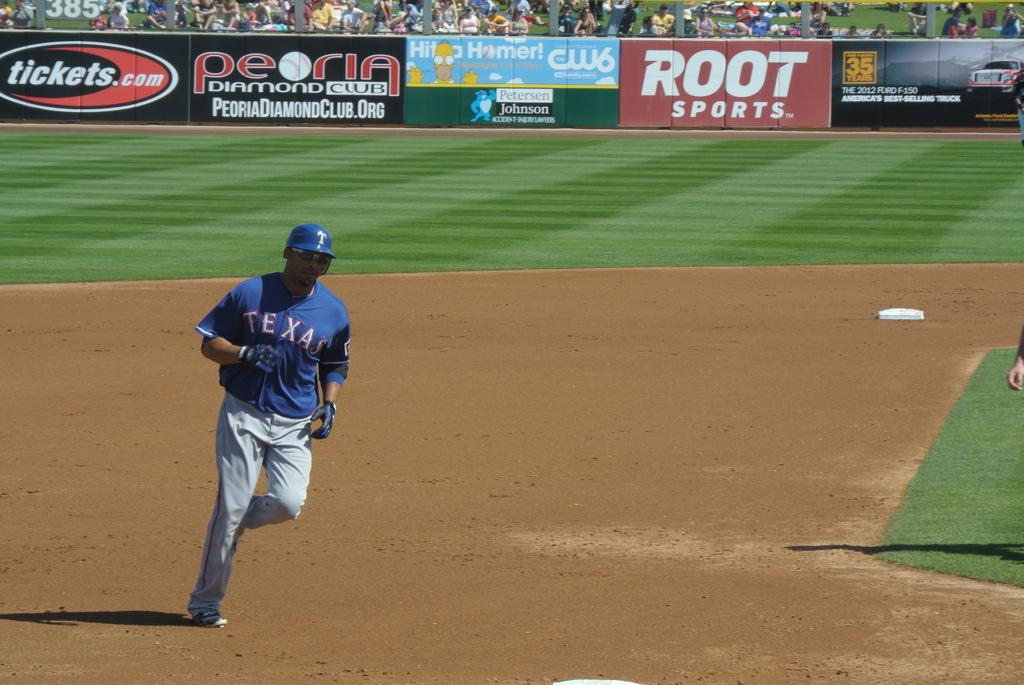<image>
Render a clear and concise summary of the photo. A baseball player with a Root sports banner in the background 